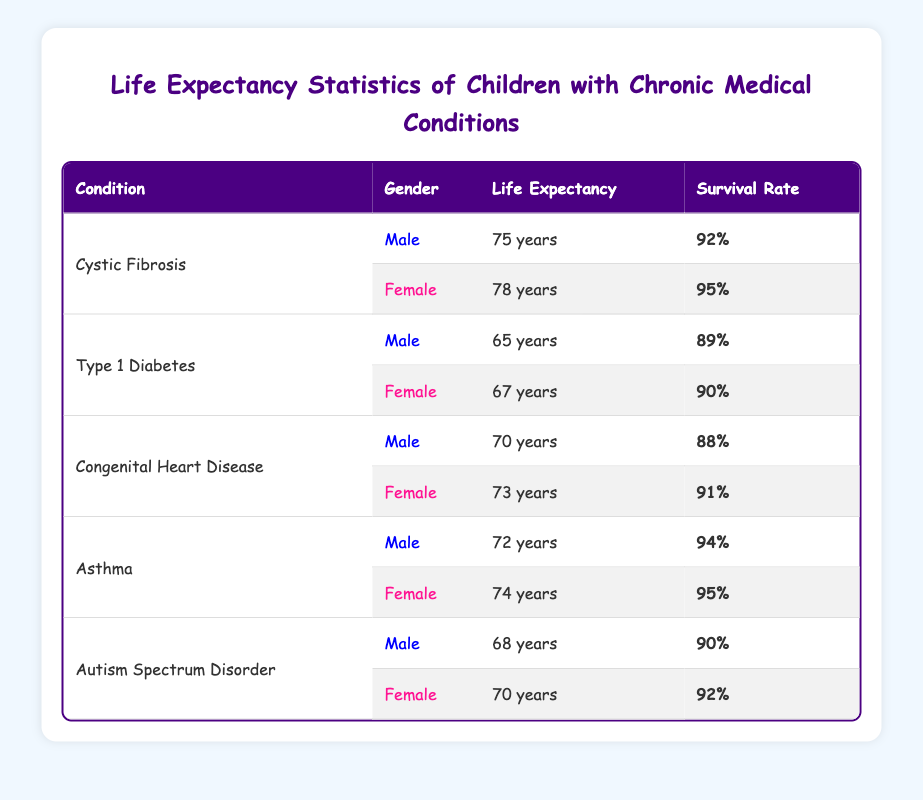What is the life expectancy for males with Type 1 Diabetes? The life expectancy for males with Type 1 Diabetes is listed as 65 years in the table.
Answer: 65 years What is the survival rate for females with Cystic Fibrosis? The survival rate for females with Cystic Fibrosis is 95%, as indicated in the table.
Answer: 95% Which chronic condition has the highest life expectancy for males? Comparing the life expectancies of males across different conditions, Cystic Fibrosis has the highest life expectancy at 75 years.
Answer: Cystic Fibrosis What is the average life expectancy for females across all conditions? The life expectancies for females are 78, 67, 73, 74, and 70 years. To find the average, we sum these values (78 + 67 + 73 + 74 + 70) = 362 and divide by 5, resulting in an average of 72.4 years.
Answer: 72.4 years Do males with Asthma have a survival rate above 90%? The survival rate for males with Asthma is 94%, which is indeed above 90%.
Answer: Yes What is the difference in life expectancy between males and females with Congenital Heart Disease? The life expectancy for males with Congenital Heart Disease is 70 years and for females, it is 73 years. The difference is calculated by subtracting the male value from the female value (73 - 70) = 3 years.
Answer: 3 years Is the survival rate for females with Autism Spectrum Disorder greater than that for males with the same condition? The survival rate for females with Autism Spectrum Disorder is 92%, while for males it is 90%, indicating that the female survival rate is indeed greater.
Answer: Yes What is the total life expectancy for all males listed in the table? The life expectancies for males listed are 75, 65, 70, 72, and 68 years. Adding these together gives a total of (75 + 65 + 70 + 72 + 68) = 350 years.
Answer: 350 years What condition has the lowest life expectancy for females? On reviewing the life expectancies for females, Type 1 Diabetes has the lowest at 67 years when compared to others like Asthma and Cystic Fibrosis.
Answer: Type 1 Diabetes 